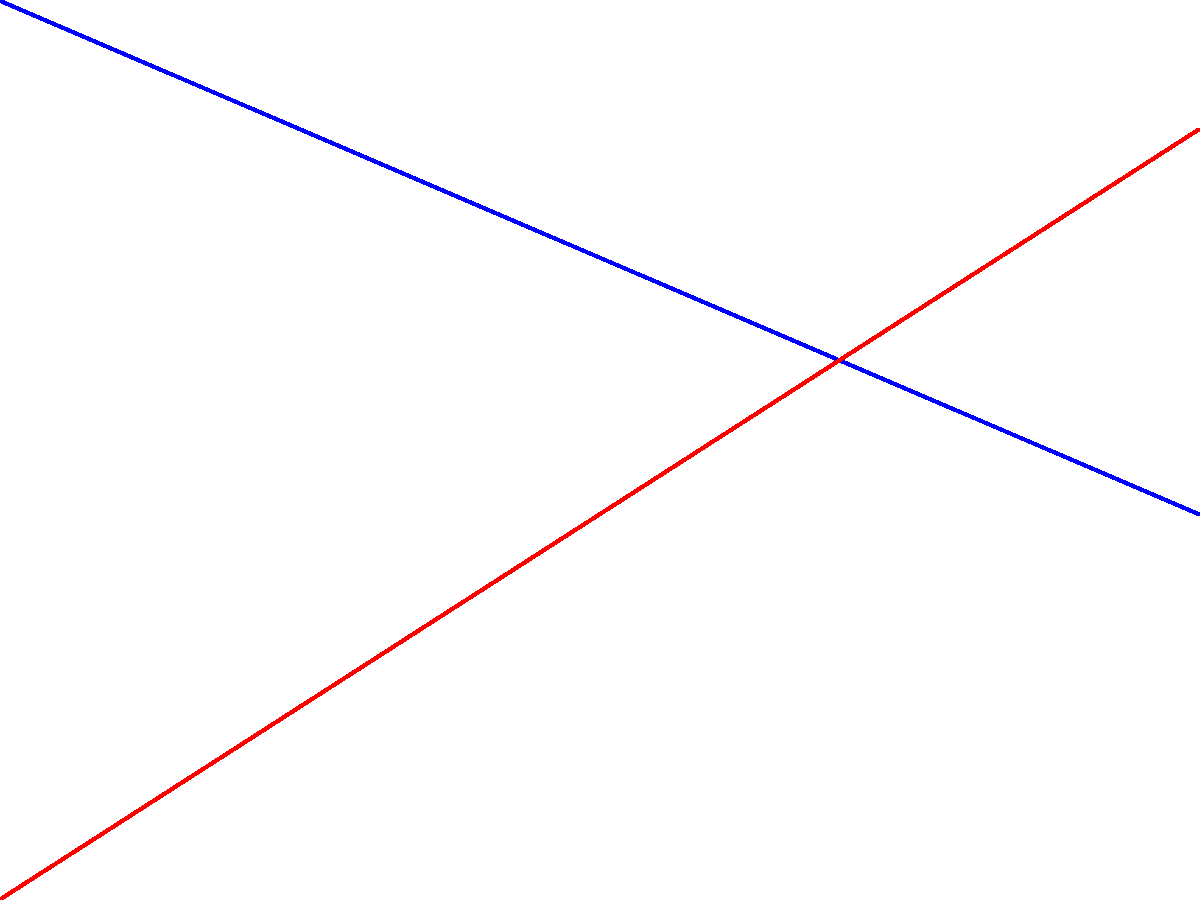Based on the graph showing viewer ratings for Cable TV and Streaming Services over a 10-year period, in which year do the ratings for these two services intersect? What implications does this have for the cable television industry? To find the intersection point, we need to follow these steps:

1. Identify the equations for both lines:
   Cable TV: $y = 80 - 4x$
   Streaming Services: $y = 10 + 6x$

2. Set the equations equal to each other:
   $80 - 4x = 10 + 6x$

3. Solve for $x$:
   $70 = 10x$
   $x = 7$

4. This means the lines intersect at year 7.

5. Implications for the cable television industry:
   a) The graph shows a steady decline in cable TV viewership.
   b) Streaming services are rapidly gaining popularity.
   c) At the intersection point (year 7), both services have equal viewer ratings.
   d) After year 7, streaming services surpass cable TV in viewership.
   e) This trend suggests a significant shift in consumer preferences, posing a threat to traditional cable TV business models.
   f) The cable industry needs to innovate or adapt to maintain relevance in the changing market.
Answer: Year 7; indicates a critical shift in viewer preferences, threatening traditional cable TV's dominance. 